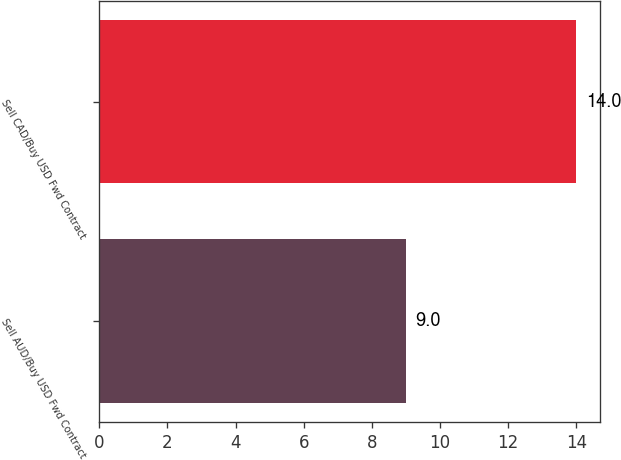<chart> <loc_0><loc_0><loc_500><loc_500><bar_chart><fcel>Sell AUD/Buy USD Fwd Contract<fcel>Sell CAD/Buy USD Fwd Contract<nl><fcel>9<fcel>14<nl></chart> 